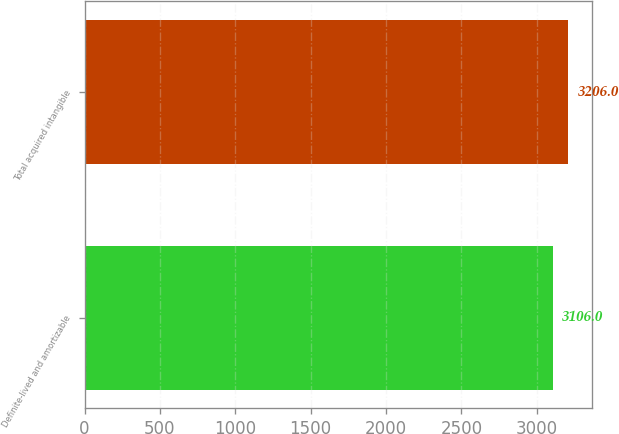Convert chart. <chart><loc_0><loc_0><loc_500><loc_500><bar_chart><fcel>Definite-lived and amortizable<fcel>Total acquired intangible<nl><fcel>3106<fcel>3206<nl></chart> 